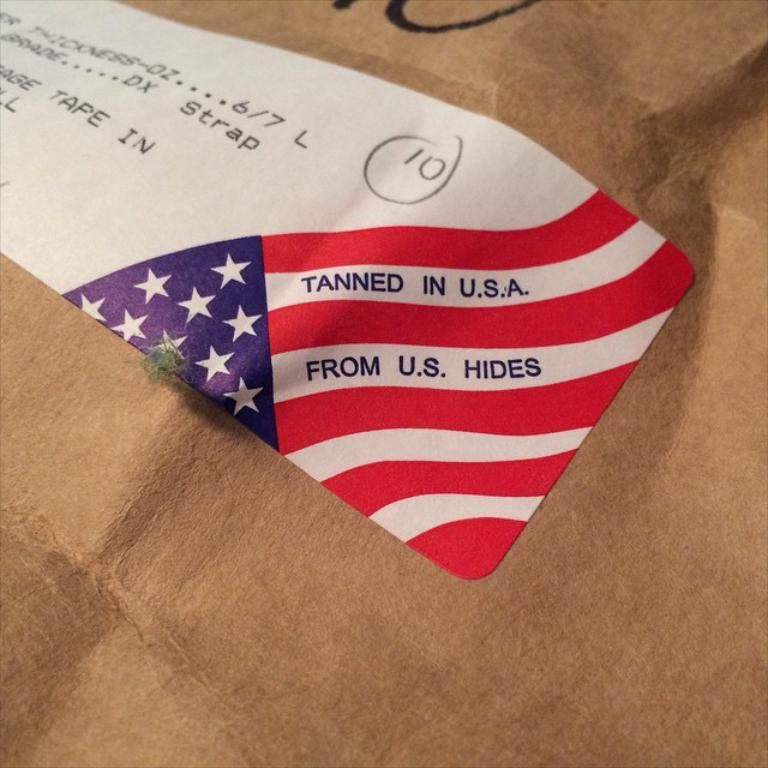<image>
Give a short and clear explanation of the subsequent image. A tag that says is was made in the USA 